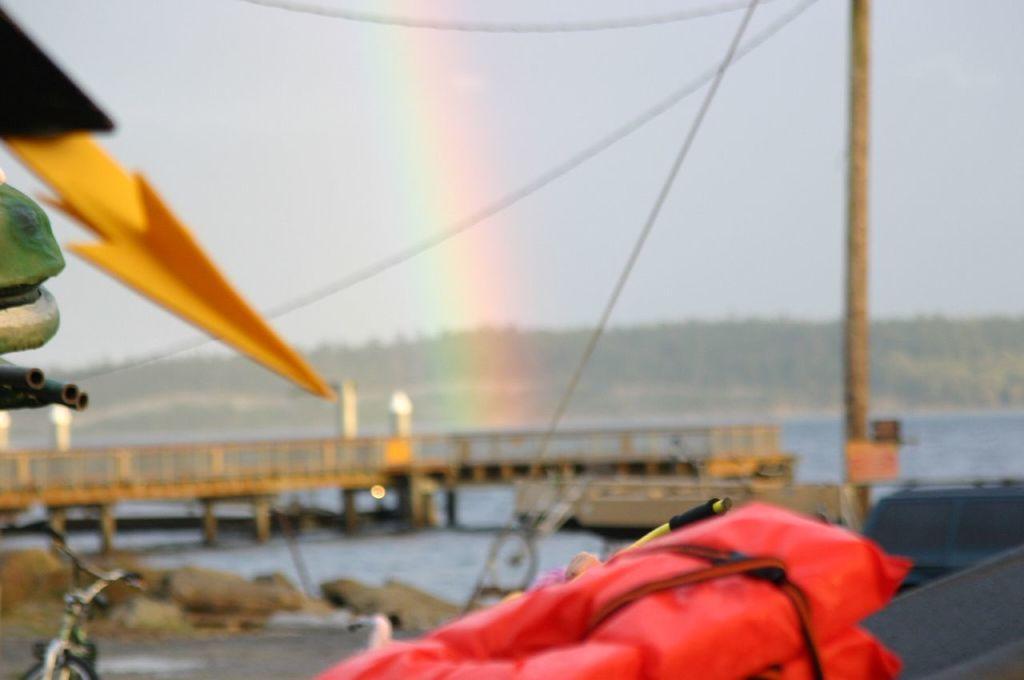How would you summarize this image in a sentence or two? In the picture we can see a red color bag with some threads tied to it and beside it we can see a yellow color arrow and behind it we can see a pole with wires to it and far away from it we can see water and a bridge on it with railing and behind it we can see hills with trees, rainbow and a sky. 